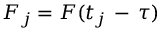Convert formula to latex. <formula><loc_0><loc_0><loc_500><loc_500>F _ { j } = F ( t _ { j } \, - \, \tau )</formula> 